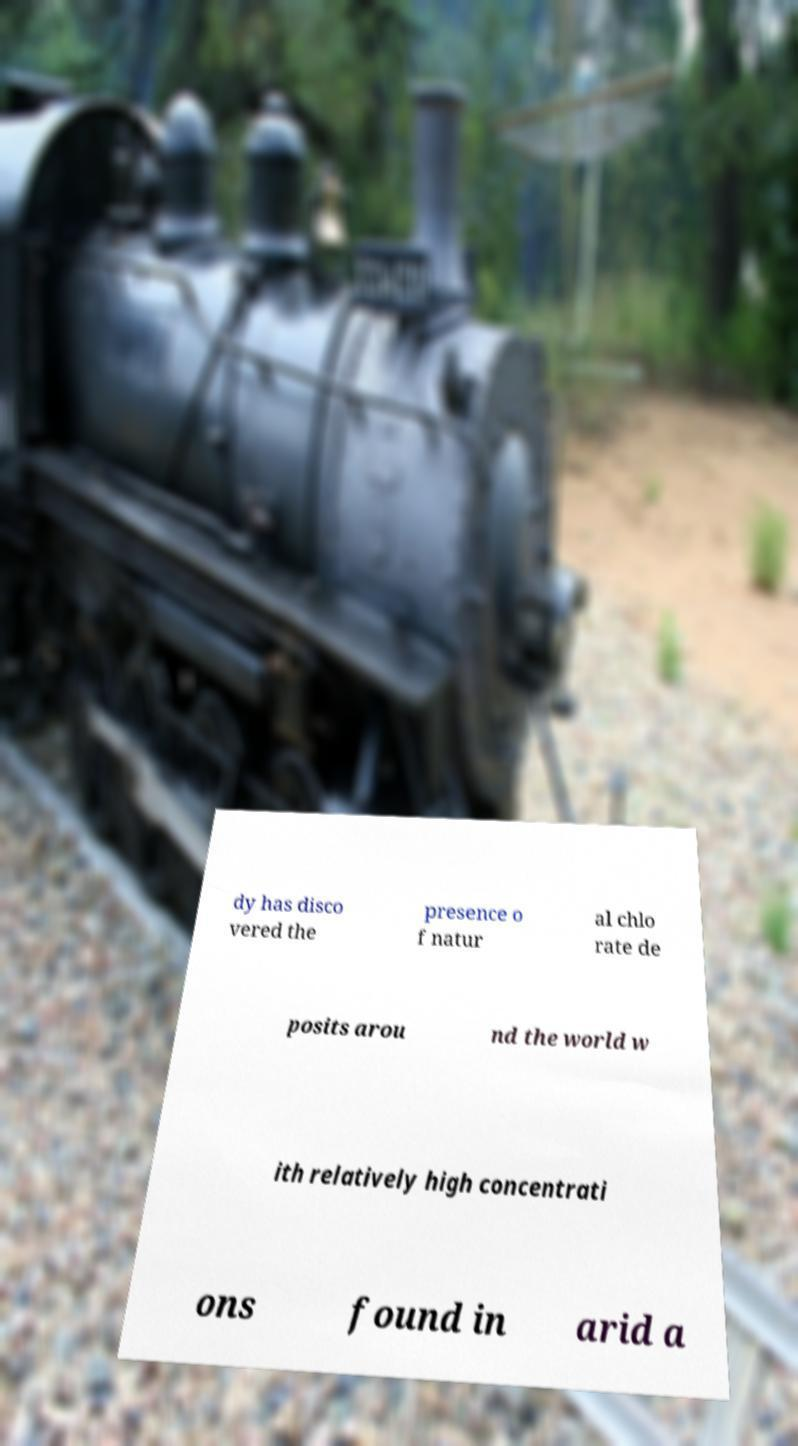Could you assist in decoding the text presented in this image and type it out clearly? dy has disco vered the presence o f natur al chlo rate de posits arou nd the world w ith relatively high concentrati ons found in arid a 